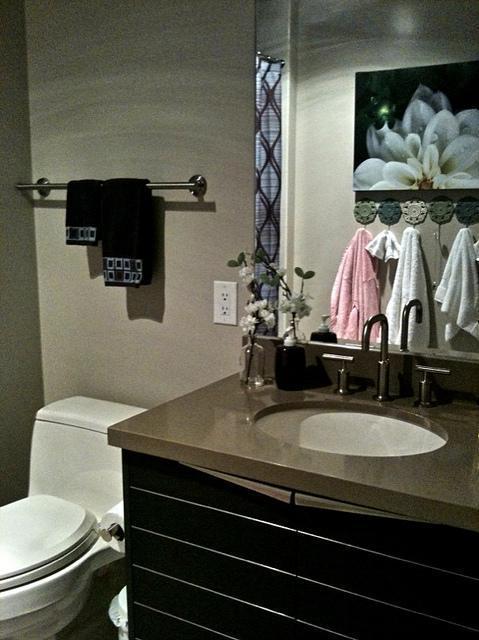What is likely opposite the toilet?
Indicate the correct response and explain using: 'Answer: answer
Rationale: rationale.'
Options: Closet, bedroom door, bathtub, vanity. Answer: bathtub.
Rationale: The bathroom shows a mirror with bath towels in the reflection so there must be a bathtub in the room. 